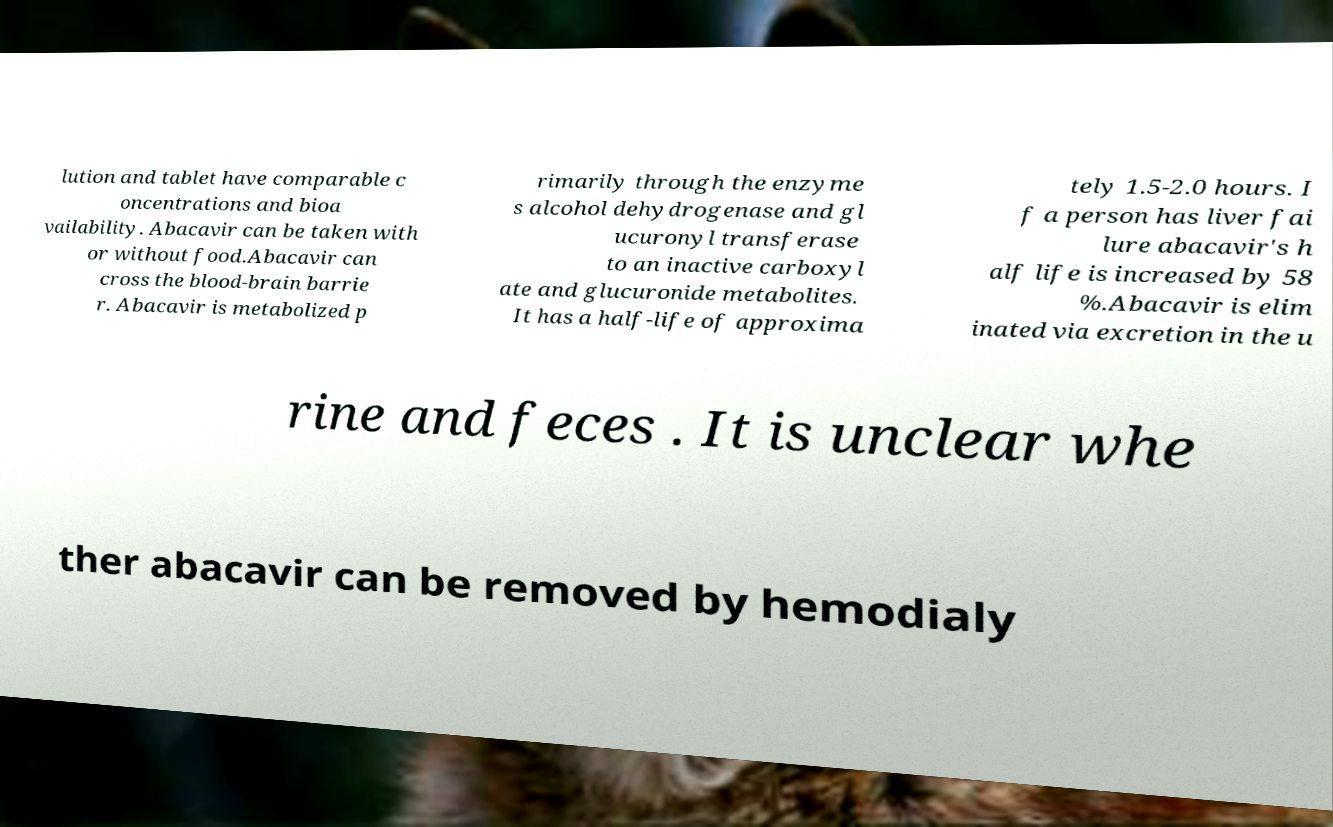There's text embedded in this image that I need extracted. Can you transcribe it verbatim? lution and tablet have comparable c oncentrations and bioa vailability. Abacavir can be taken with or without food.Abacavir can cross the blood-brain barrie r. Abacavir is metabolized p rimarily through the enzyme s alcohol dehydrogenase and gl ucuronyl transferase to an inactive carboxyl ate and glucuronide metabolites. It has a half-life of approxima tely 1.5-2.0 hours. I f a person has liver fai lure abacavir's h alf life is increased by 58 %.Abacavir is elim inated via excretion in the u rine and feces . It is unclear whe ther abacavir can be removed by hemodialy 